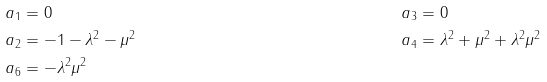<formula> <loc_0><loc_0><loc_500><loc_500>a _ { 1 } & = 0 & a _ { 3 } & = 0 \\ a _ { 2 } & = - 1 - \lambda ^ { 2 } - \mu ^ { 2 } & a _ { 4 } & = \lambda ^ { 2 } + \mu ^ { 2 } + \lambda ^ { 2 } \mu ^ { 2 } \\ a _ { 6 } & = - \lambda ^ { 2 } \mu ^ { 2 } & &</formula> 